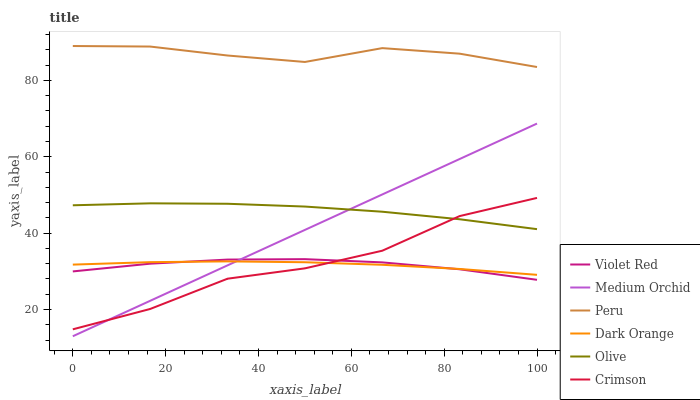Does Violet Red have the minimum area under the curve?
Answer yes or no. Yes. Does Peru have the maximum area under the curve?
Answer yes or no. Yes. Does Medium Orchid have the minimum area under the curve?
Answer yes or no. No. Does Medium Orchid have the maximum area under the curve?
Answer yes or no. No. Is Medium Orchid the smoothest?
Answer yes or no. Yes. Is Crimson the roughest?
Answer yes or no. Yes. Is Violet Red the smoothest?
Answer yes or no. No. Is Violet Red the roughest?
Answer yes or no. No. Does Medium Orchid have the lowest value?
Answer yes or no. Yes. Does Violet Red have the lowest value?
Answer yes or no. No. Does Peru have the highest value?
Answer yes or no. Yes. Does Violet Red have the highest value?
Answer yes or no. No. Is Violet Red less than Olive?
Answer yes or no. Yes. Is Peru greater than Medium Orchid?
Answer yes or no. Yes. Does Crimson intersect Medium Orchid?
Answer yes or no. Yes. Is Crimson less than Medium Orchid?
Answer yes or no. No. Is Crimson greater than Medium Orchid?
Answer yes or no. No. Does Violet Red intersect Olive?
Answer yes or no. No. 